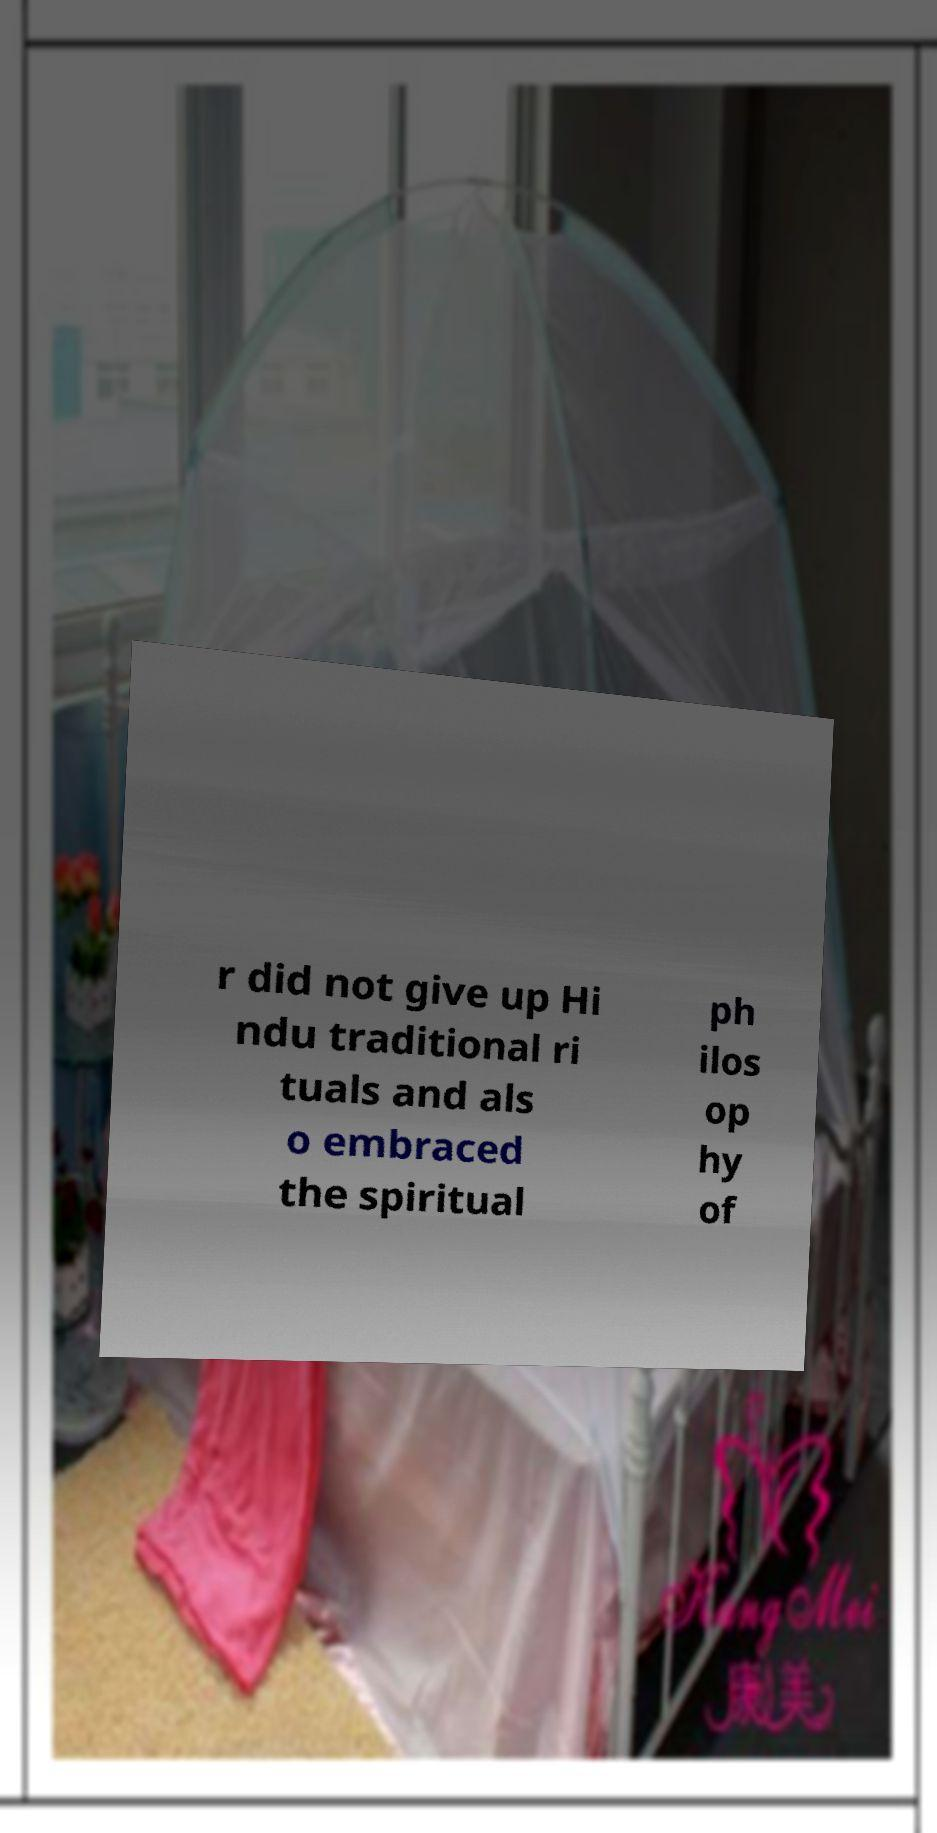Can you read and provide the text displayed in the image?This photo seems to have some interesting text. Can you extract and type it out for me? r did not give up Hi ndu traditional ri tuals and als o embraced the spiritual ph ilos op hy of 